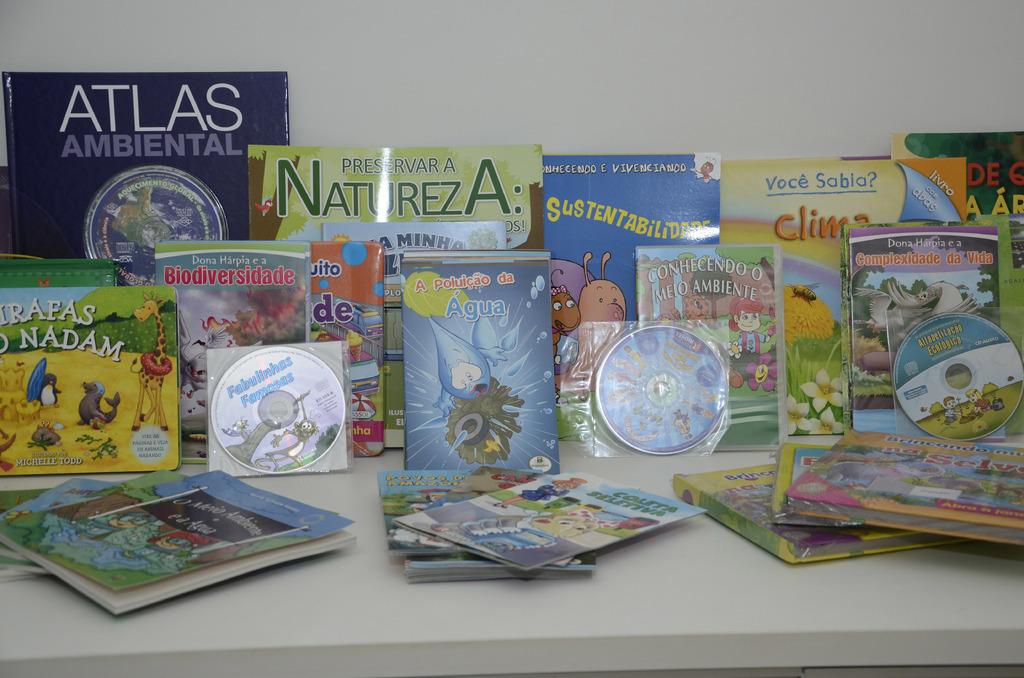What is the large blue book on the left?
Offer a terse response. Atlas ambiental. What is the green book in the middle?
Provide a short and direct response. Natureza. 